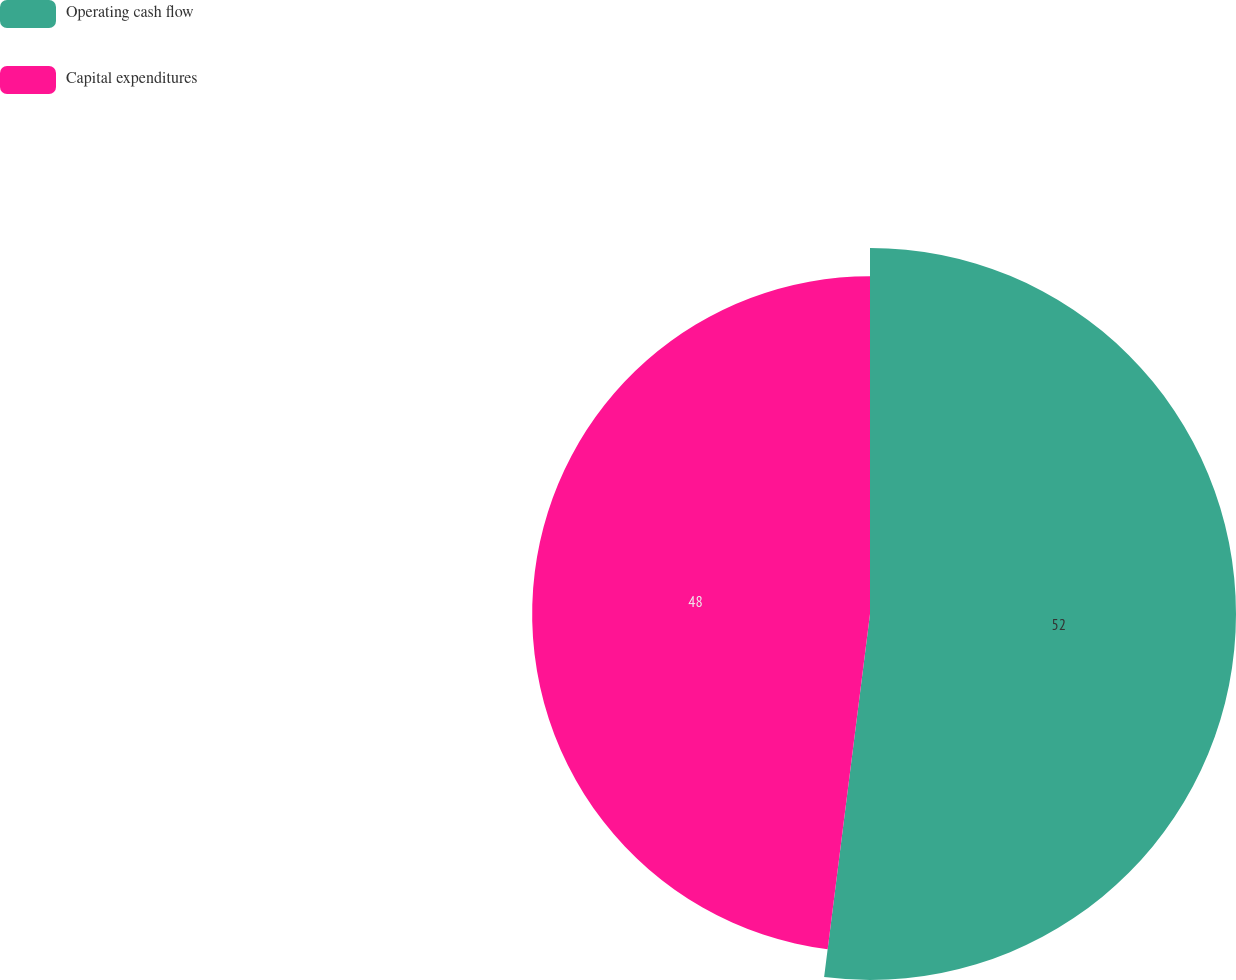Convert chart to OTSL. <chart><loc_0><loc_0><loc_500><loc_500><pie_chart><fcel>Operating cash flow<fcel>Capital expenditures<nl><fcel>52.0%<fcel>48.0%<nl></chart> 